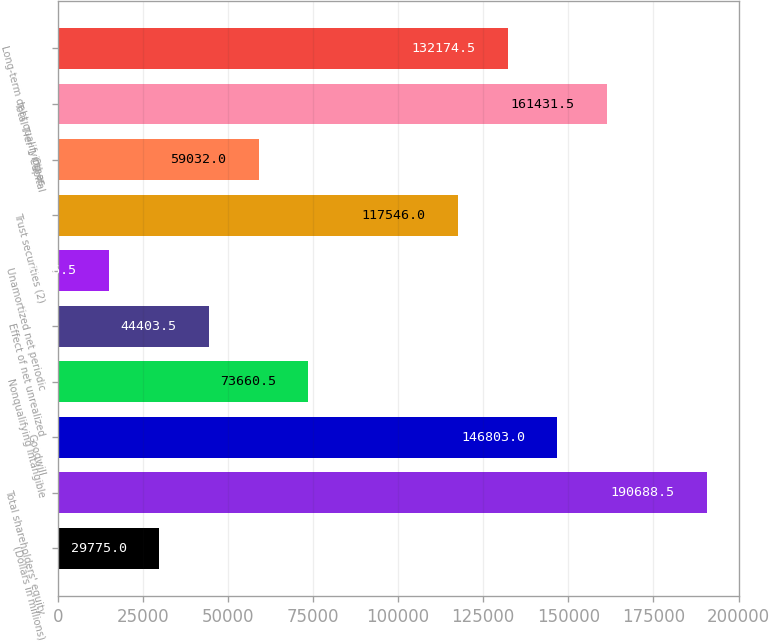<chart> <loc_0><loc_0><loc_500><loc_500><bar_chart><fcel>(Dollars in millions)<fcel>Total shareholders' equity<fcel>Goodwill<fcel>Nonqualifying intangible<fcel>Effect of net unrealized<fcel>Unamortized net periodic<fcel>Trust securities (2)<fcel>Other<fcel>Total Tier 1 Capital<fcel>Long-term debt qualifying as<nl><fcel>29775<fcel>190688<fcel>146803<fcel>73660.5<fcel>44403.5<fcel>15146.5<fcel>117546<fcel>59032<fcel>161432<fcel>132174<nl></chart> 